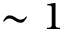<formula> <loc_0><loc_0><loc_500><loc_500>\sim 1</formula> 